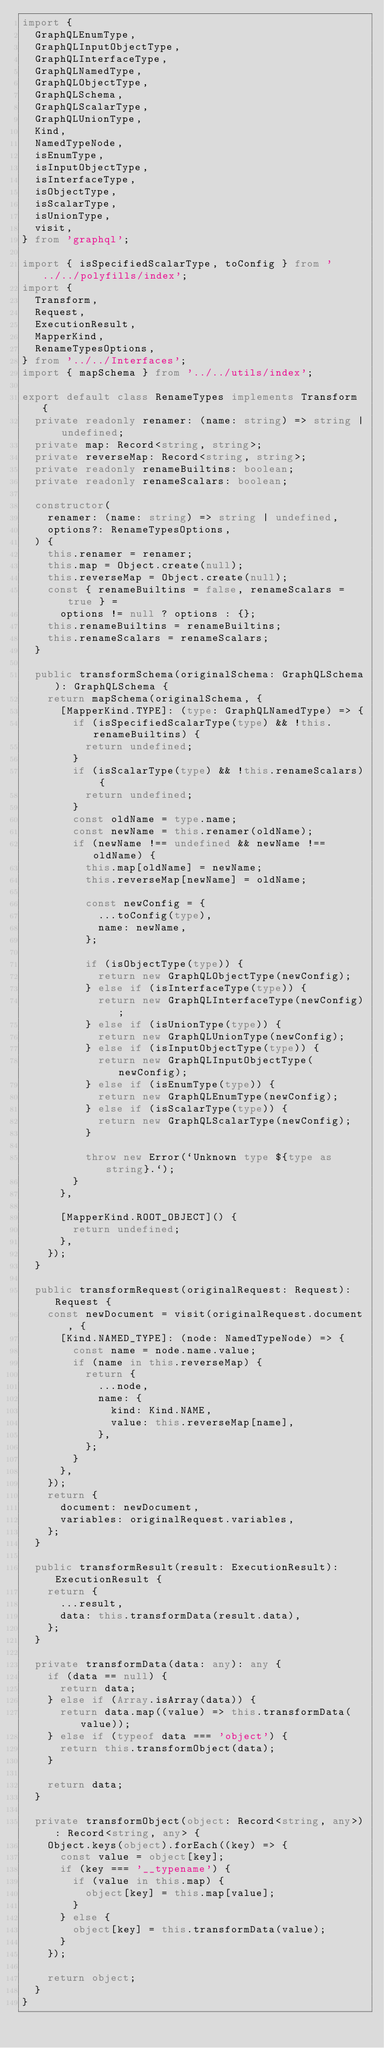Convert code to text. <code><loc_0><loc_0><loc_500><loc_500><_TypeScript_>import {
  GraphQLEnumType,
  GraphQLInputObjectType,
  GraphQLInterfaceType,
  GraphQLNamedType,
  GraphQLObjectType,
  GraphQLSchema,
  GraphQLScalarType,
  GraphQLUnionType,
  Kind,
  NamedTypeNode,
  isEnumType,
  isInputObjectType,
  isInterfaceType,
  isObjectType,
  isScalarType,
  isUnionType,
  visit,
} from 'graphql';

import { isSpecifiedScalarType, toConfig } from '../../polyfills/index';
import {
  Transform,
  Request,
  ExecutionResult,
  MapperKind,
  RenameTypesOptions,
} from '../../Interfaces';
import { mapSchema } from '../../utils/index';

export default class RenameTypes implements Transform {
  private readonly renamer: (name: string) => string | undefined;
  private map: Record<string, string>;
  private reverseMap: Record<string, string>;
  private readonly renameBuiltins: boolean;
  private readonly renameScalars: boolean;

  constructor(
    renamer: (name: string) => string | undefined,
    options?: RenameTypesOptions,
  ) {
    this.renamer = renamer;
    this.map = Object.create(null);
    this.reverseMap = Object.create(null);
    const { renameBuiltins = false, renameScalars = true } =
      options != null ? options : {};
    this.renameBuiltins = renameBuiltins;
    this.renameScalars = renameScalars;
  }

  public transformSchema(originalSchema: GraphQLSchema): GraphQLSchema {
    return mapSchema(originalSchema, {
      [MapperKind.TYPE]: (type: GraphQLNamedType) => {
        if (isSpecifiedScalarType(type) && !this.renameBuiltins) {
          return undefined;
        }
        if (isScalarType(type) && !this.renameScalars) {
          return undefined;
        }
        const oldName = type.name;
        const newName = this.renamer(oldName);
        if (newName !== undefined && newName !== oldName) {
          this.map[oldName] = newName;
          this.reverseMap[newName] = oldName;

          const newConfig = {
            ...toConfig(type),
            name: newName,
          };

          if (isObjectType(type)) {
            return new GraphQLObjectType(newConfig);
          } else if (isInterfaceType(type)) {
            return new GraphQLInterfaceType(newConfig);
          } else if (isUnionType(type)) {
            return new GraphQLUnionType(newConfig);
          } else if (isInputObjectType(type)) {
            return new GraphQLInputObjectType(newConfig);
          } else if (isEnumType(type)) {
            return new GraphQLEnumType(newConfig);
          } else if (isScalarType(type)) {
            return new GraphQLScalarType(newConfig);
          }

          throw new Error(`Unknown type ${type as string}.`);
        }
      },

      [MapperKind.ROOT_OBJECT]() {
        return undefined;
      },
    });
  }

  public transformRequest(originalRequest: Request): Request {
    const newDocument = visit(originalRequest.document, {
      [Kind.NAMED_TYPE]: (node: NamedTypeNode) => {
        const name = node.name.value;
        if (name in this.reverseMap) {
          return {
            ...node,
            name: {
              kind: Kind.NAME,
              value: this.reverseMap[name],
            },
          };
        }
      },
    });
    return {
      document: newDocument,
      variables: originalRequest.variables,
    };
  }

  public transformResult(result: ExecutionResult): ExecutionResult {
    return {
      ...result,
      data: this.transformData(result.data),
    };
  }

  private transformData(data: any): any {
    if (data == null) {
      return data;
    } else if (Array.isArray(data)) {
      return data.map((value) => this.transformData(value));
    } else if (typeof data === 'object') {
      return this.transformObject(data);
    }

    return data;
  }

  private transformObject(object: Record<string, any>): Record<string, any> {
    Object.keys(object).forEach((key) => {
      const value = object[key];
      if (key === '__typename') {
        if (value in this.map) {
          object[key] = this.map[value];
        }
      } else {
        object[key] = this.transformData(value);
      }
    });

    return object;
  }
}
</code> 